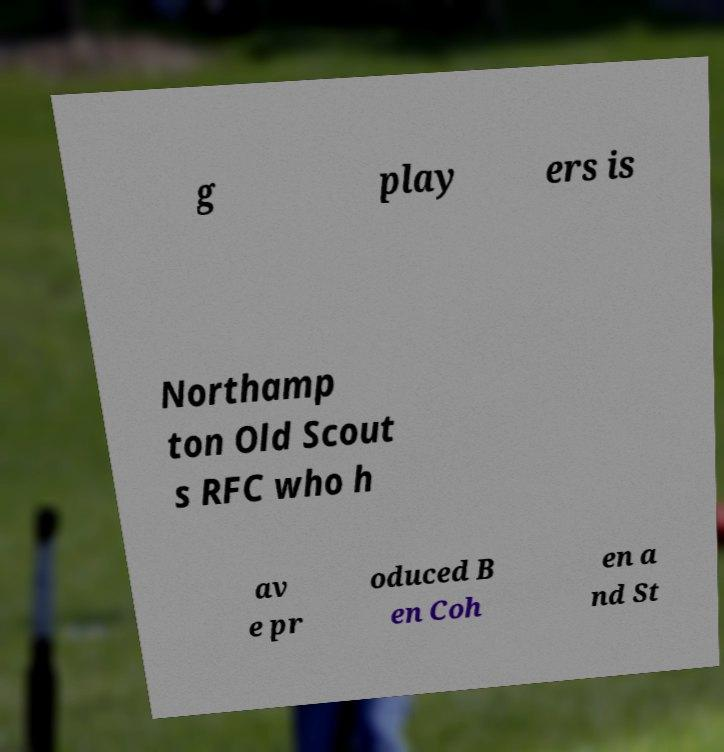For documentation purposes, I need the text within this image transcribed. Could you provide that? g play ers is Northamp ton Old Scout s RFC who h av e pr oduced B en Coh en a nd St 